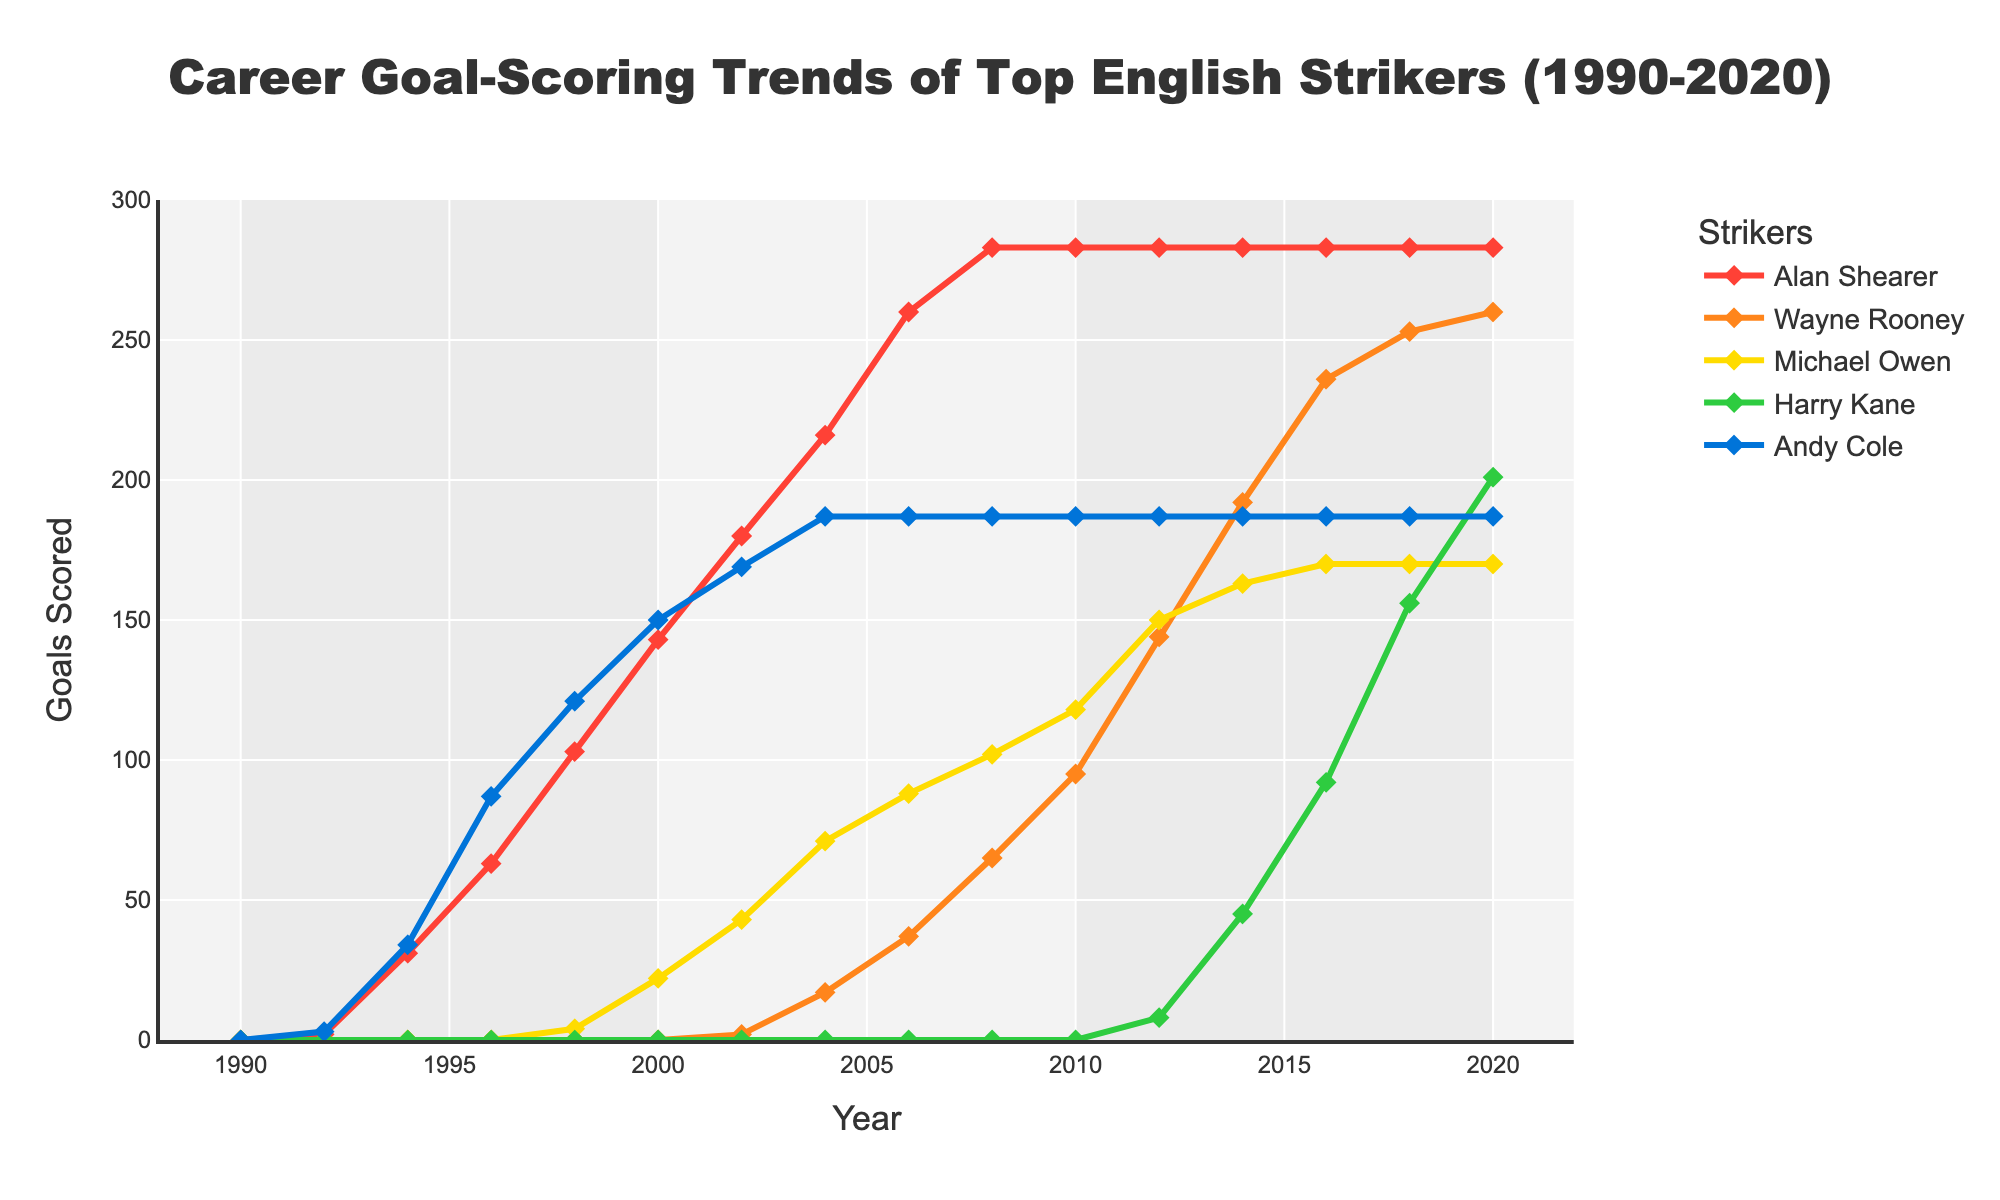Which striker scored the most goals in 2010? Look at the figure and identify the striker with the highest data point in 2010.
Answer: Michael Owen How many goals did Wayne Rooney score between 2002 and 2012? Subtract Rooney's score in 2002 from his score in 2012. Explanation: 144 (2012) - 2 (2002).
Answer: 142 Between 2014 and 2016, who had the largest increase in goals? Compare the increase in goals between 2014 and 2016 for all strikers. Explanation: Harry Kane's score increased from 45 to 92.
Answer: Harry Kane Which striker's career goal trend was flat from 2010 to 2020? Identify the striker whose goal count remained unchanged over this period. Alan Shearer’s data points at 283 did not change from 2010 to 2020.
Answer: Alan Shearer How many total goals were scored by all strikers in 2004? Sum the goals of all strikers in 2004: 216 (Shearer) + 17 (Rooney) + 71 (Owen) + 0 (Kane) + 187 (Cole).
Answer: 491 Who had the least number of career goals in 2018? Identify the smallest data point for 2018. Explanation: Michael Owen, Harry Kane, and Andy Cole all have fewer than 200 goals, but Andy Cole has the fewest with 187.
Answer: Andy Cole How much did Harry Kane's goal tally increase from 2012 to 2018? Subtract Kane's 2012 score from his 2018 score: 156 (2018) - 8 (2012).
Answer: 148 Compare the goal trends of Alan Shearer and Wayne Rooney. Who had higher goals in 2006? Look at the data for 2006 for both strikers. Shearer had 260, Rooney had 37.
Answer: Alan Shearer What was the difference in goals scored by Michael Owen and Andy Cole in 2000? Subtract Cole's 2000 score from Owen's 2000 score: 22 (Owen) - 150 (Cole).
Answer: -128 